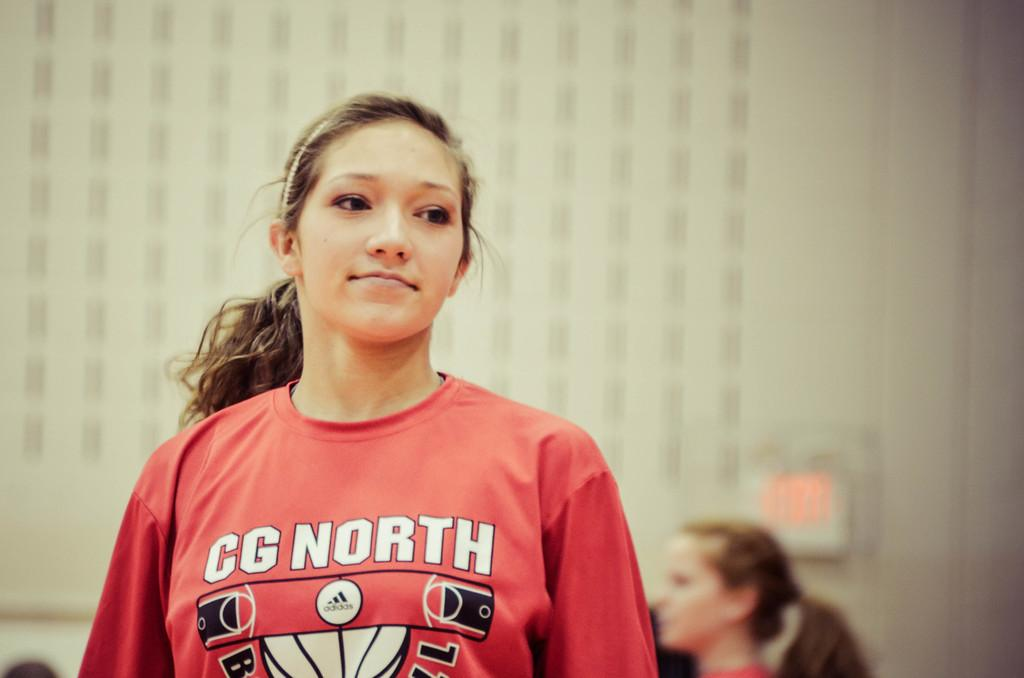Provide a one-sentence caption for the provided image. A woman wearing a CG North long sleeve shirt looking distracted and behind her another woman looking to the forward to the left of the woman in front. 